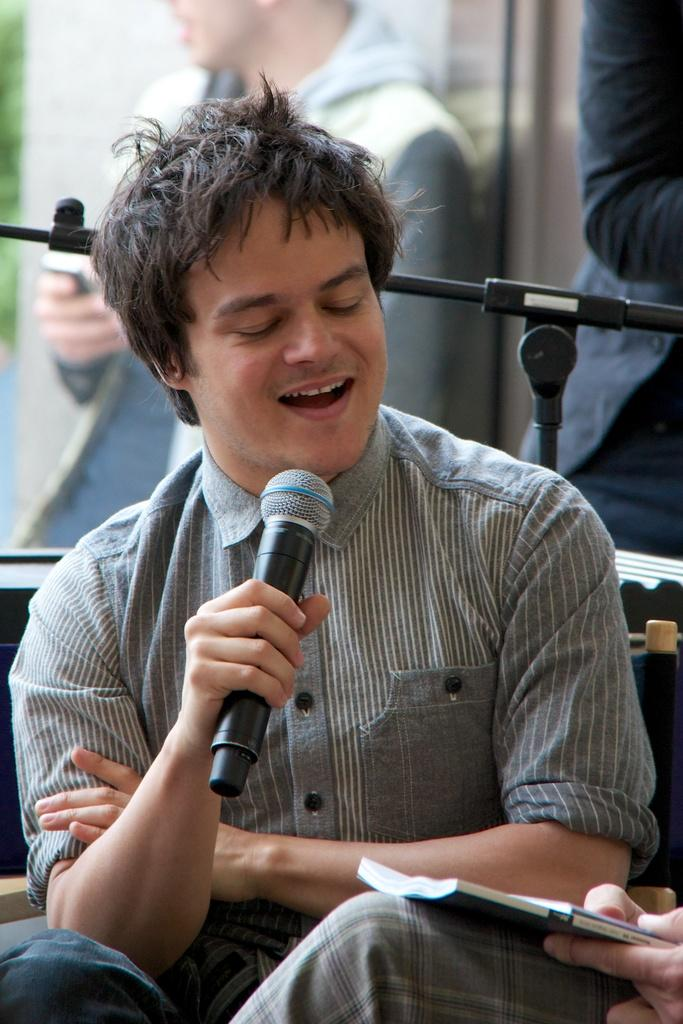What is the man in the image doing? The man is sitting and singing, with his eyes closed. What is the man holding in the image? The man is holding a microphone. What is the man wearing in the image? The man is wearing a shirt with stripes. What is present behind the man in the image? There is a microphone stand behind the man. Are there any other people visible in the image? Yes, there are people visible in the image. What type of worm can be seen crawling on the man's shirt in the image? There is no worm present on the man's shirt in the image. Can you tell me how many robins are perched on the microphone stand in the image? There are no robins present on the microphone stand in the image. 